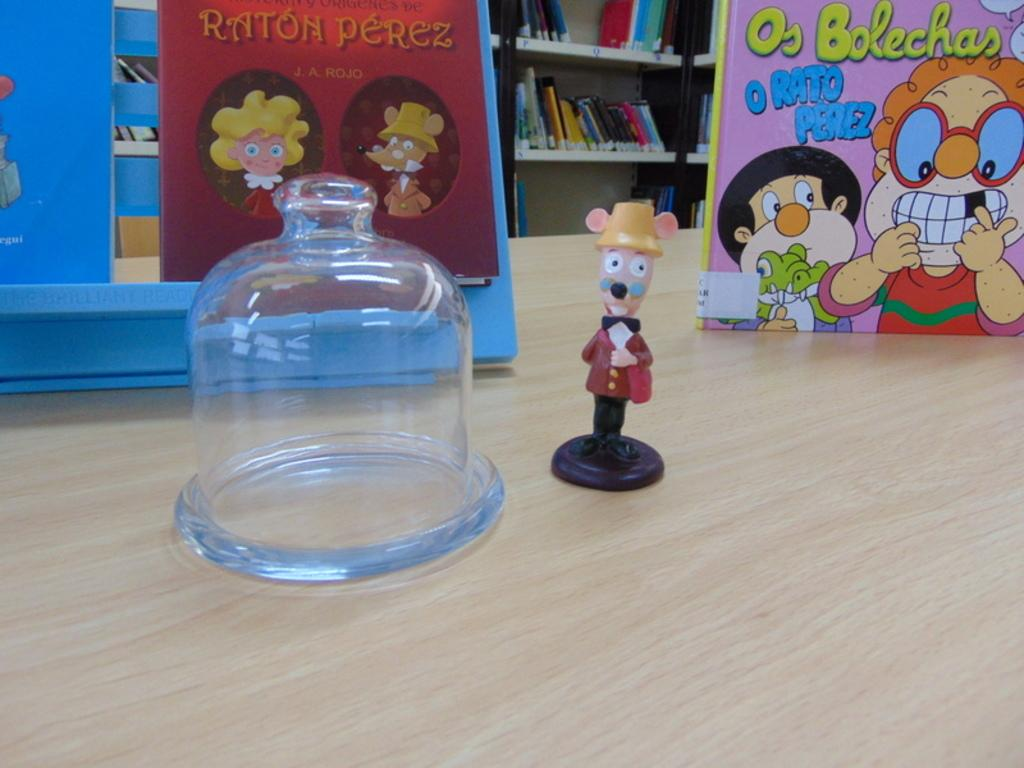<image>
Write a terse but informative summary of the picture. A toy is on the table with a book written by Raton Perez in the background. 